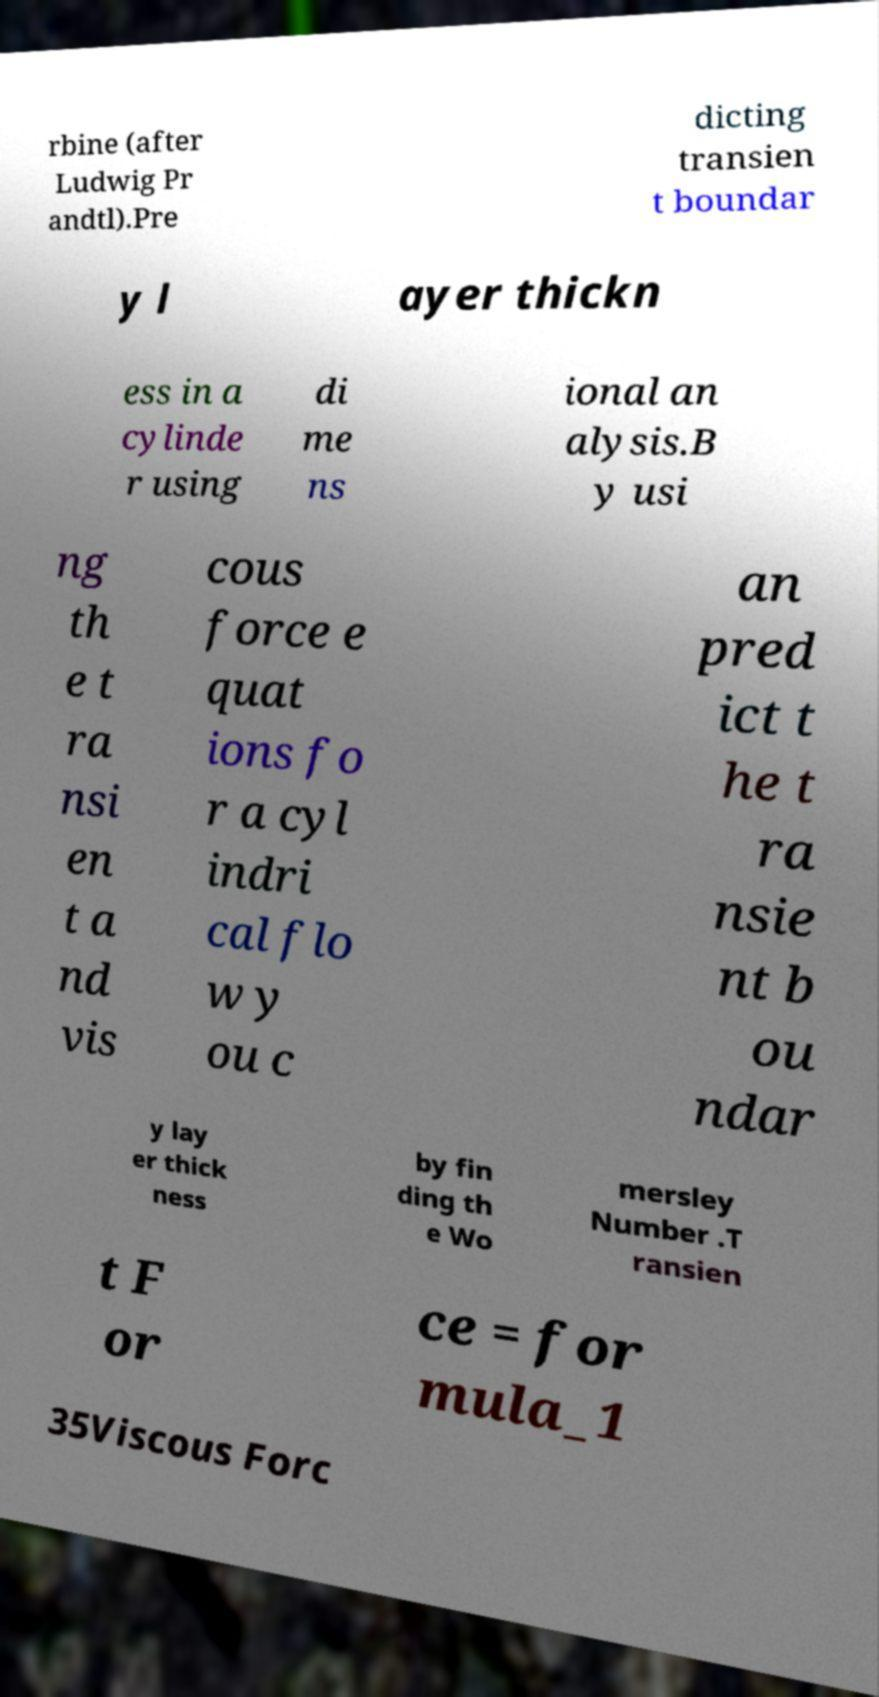I need the written content from this picture converted into text. Can you do that? rbine (after Ludwig Pr andtl).Pre dicting transien t boundar y l ayer thickn ess in a cylinde r using di me ns ional an alysis.B y usi ng th e t ra nsi en t a nd vis cous force e quat ions fo r a cyl indri cal flo w y ou c an pred ict t he t ra nsie nt b ou ndar y lay er thick ness by fin ding th e Wo mersley Number .T ransien t F or ce = for mula_1 35Viscous Forc 